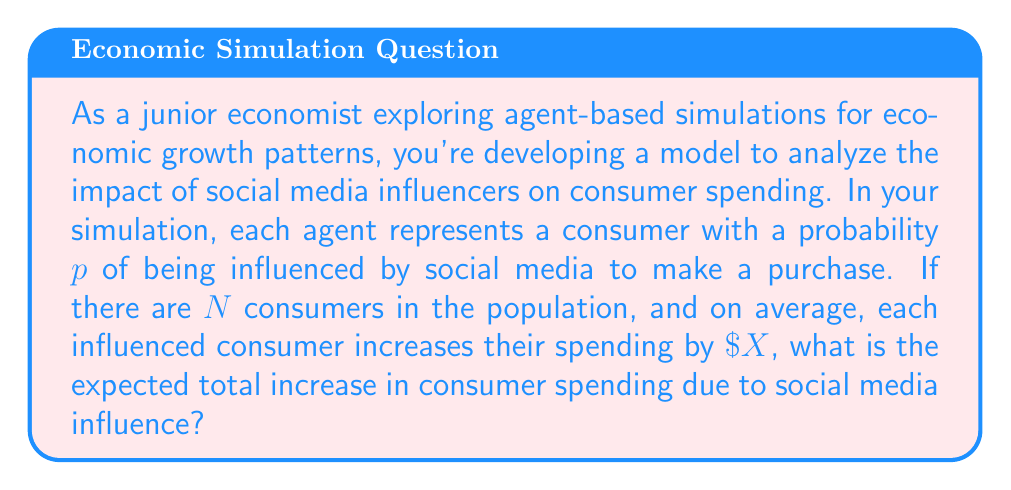Help me with this question. Let's approach this step-by-step:

1) First, we need to determine the expected number of consumers influenced by social media. Given that:
   - Total number of consumers = $N$
   - Probability of being influenced = $p$
   
   The expected number of influenced consumers is:
   $$E(\text{influenced consumers}) = N \cdot p$$

2) Now, we know that each influenced consumer increases their spending by $\$X$ on average. To find the total increase in spending, we multiply the number of influenced consumers by the average increase per consumer:

   $$\text{Total increase} = E(\text{influenced consumers}) \cdot X$$

3) Substituting the expression from step 1:

   $$\text{Total increase} = (N \cdot p) \cdot X$$

4) Simplifying:

   $$\text{Total increase} = N \cdot p \cdot X$$

This gives us the expected total increase in consumer spending due to social media influence.
Answer: $NpX$ 